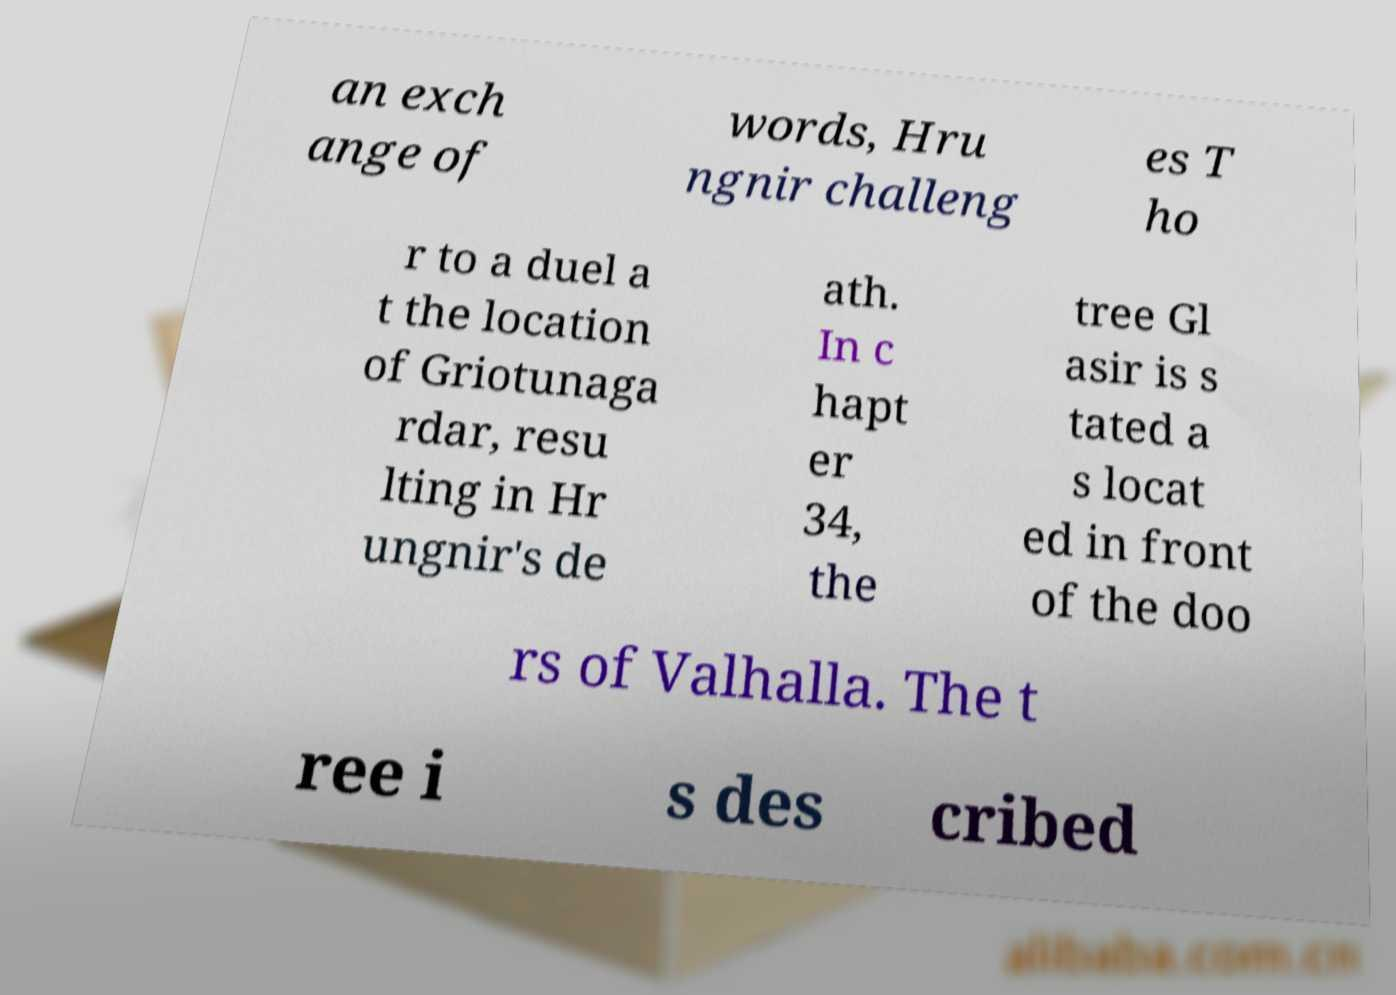For documentation purposes, I need the text within this image transcribed. Could you provide that? an exch ange of words, Hru ngnir challeng es T ho r to a duel a t the location of Griotunaga rdar, resu lting in Hr ungnir's de ath. In c hapt er 34, the tree Gl asir is s tated a s locat ed in front of the doo rs of Valhalla. The t ree i s des cribed 